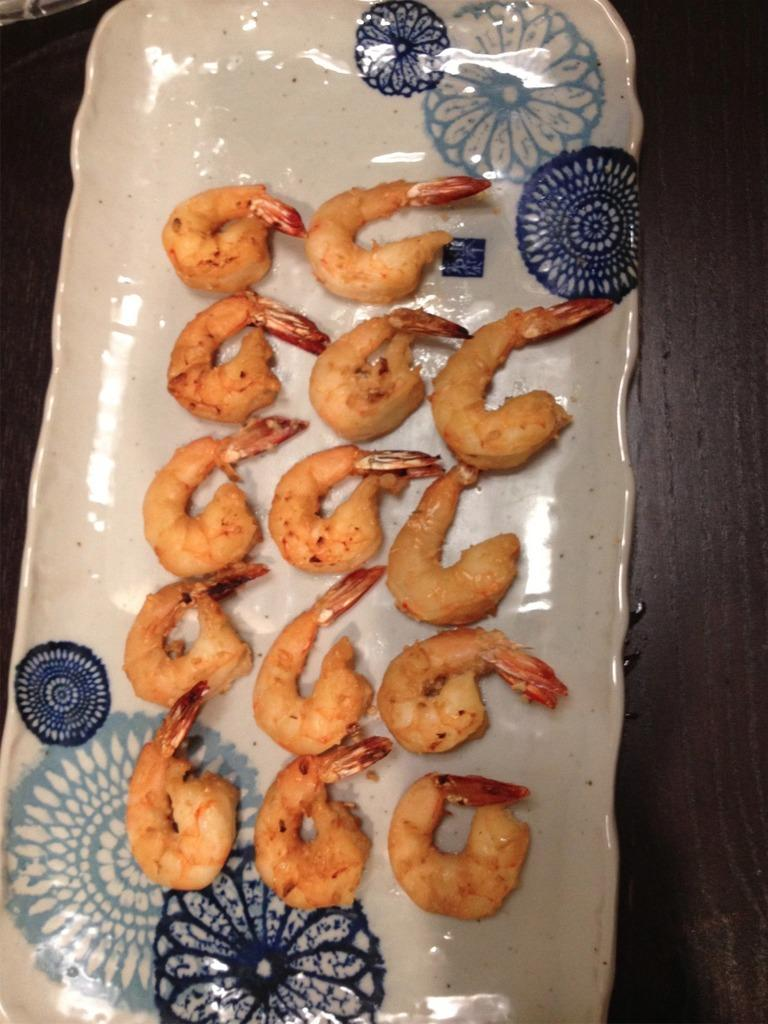What is on the plate that is visible in the image? The plate contains prawns. Where is the plate located in the image? The plate is placed on a table. What type of ornament is hanging from the boot in the image? There is no ornament or boot present in the image. 